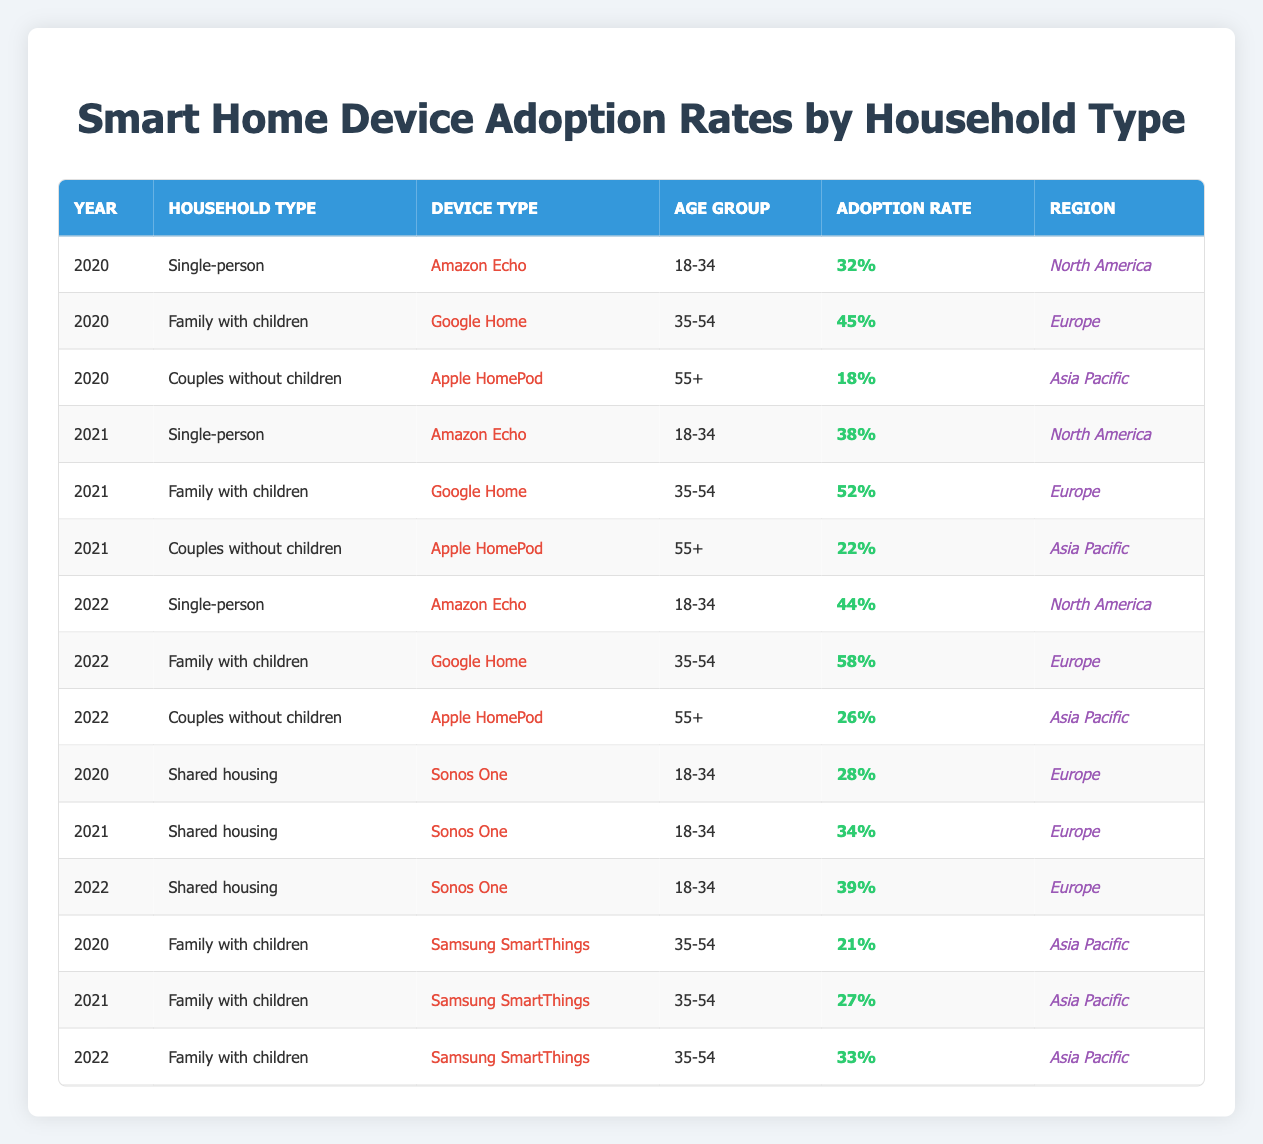What was the adoption rate of Amazon Echo in Single-person households in 2021? The table shows that in 2021, under the Single-person household type, the Amazon Echo had an adoption rate of 38%.
Answer: 38% Which device had the highest adoption rate among Family with children in 2022? Looking at the rows for Family with children in 2022, Google Home has an adoption rate of 58%, while Samsung SmartThings has 33%. Therefore, Google Home had the highest adoption rate.
Answer: Google Home True or False: The adoption rate of Sonos One in Shared housing increased every year from 2020 to 2022. By checking the adoption rates for Sonos One in Shared housing: 2020 (28%), 2021 (34%), and 2022 (39%), we see that the rates do indeed increase every year.
Answer: True What was the average adoption rate for Couples without children across all years for the Apple HomePod? The adoption rates for Couples without children using Apple HomePod are: 2020 (18%), 2021 (22%), and 2022 (26%). Adding these values gives 18 + 22 + 26 = 66; dividing by 3 gives an average of 66/3 = 22.
Answer: 22 What was the adoption rate for Samsung SmartThings in Family with children in 2020, and how does it compare to the adoption rate for the same device type and household type in 2022? In 2020, the Family with children had an adoption rate of 21% for Samsung SmartThings, while in 2022, it increased to 33%. The comparison shows an increase of 12%.
Answer: Increased by 12% from 21% to 33% What is the total adoption rate of Google Home for Family with children over the three years of data provided? The adoption rates for Google Home in Family with children are as follows: 2020 (45%), 2021 (52%), and 2022 (58%). Adding these values gives 45 + 52 + 58 = 155, which represents the total adoption rate across these years.
Answer: 155 